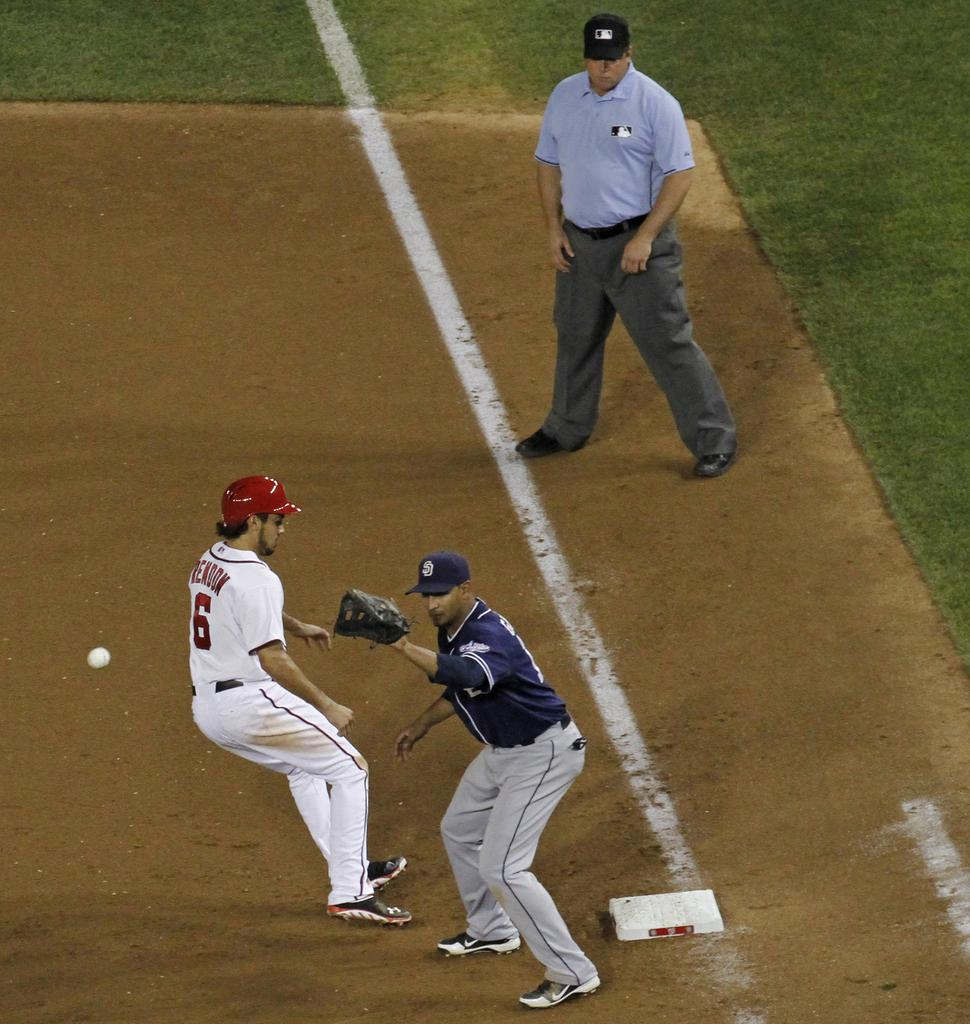Provide a one-sentence caption for the provided image. Player number 6 attempts to reach the base while playing a game of baseball. 